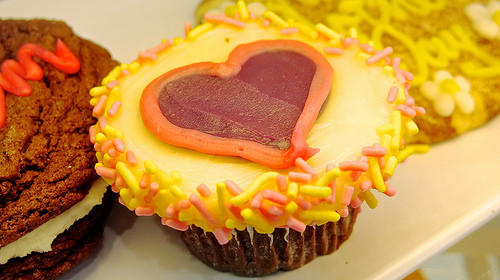<image>
Is the icing behind the heart? Yes. From this viewpoint, the icing is positioned behind the heart, with the heart partially or fully occluding the icing. 